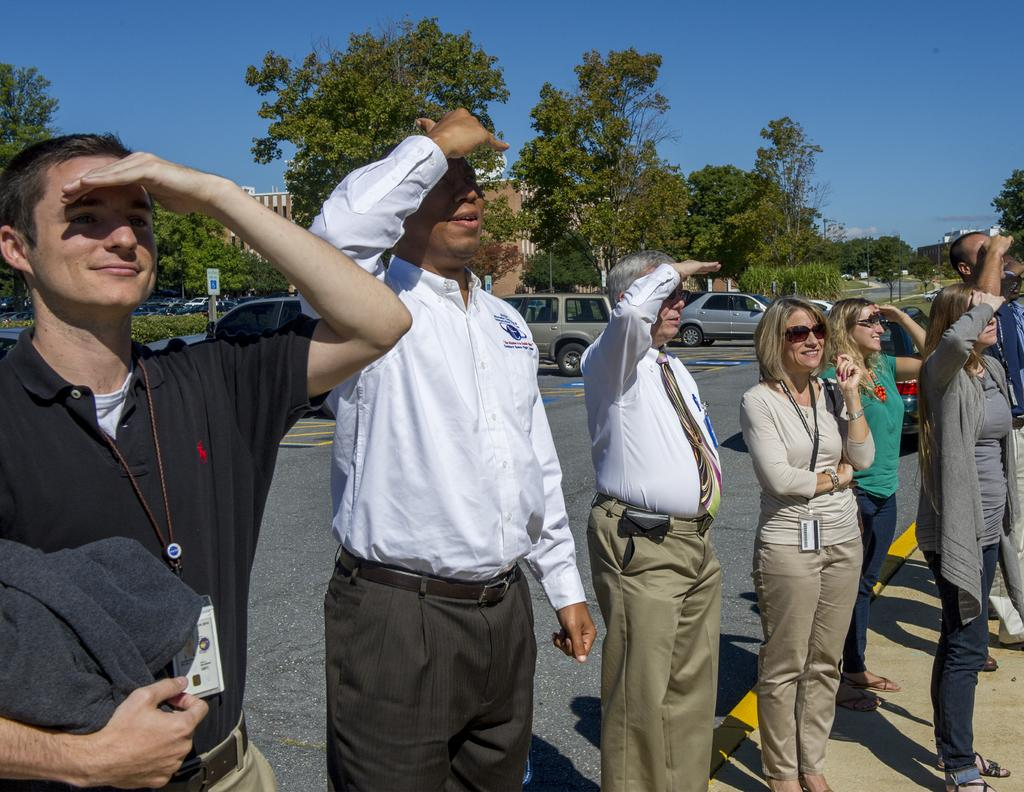What are the people in the image doing? The people in the image are standing on the road. What is behind the people on the road? There are cars behind the people. What can be seen on the sides of the road? Boards, plants, trees, and buildings are visible in the image. What is visible at the top of the image? The sky is visible at the top of the image. What type of quill is being used by the parent in the image? There is no quill or parent present in the image. What kind of bun is being served at the event in the image? There is no event or bun present in the image. 